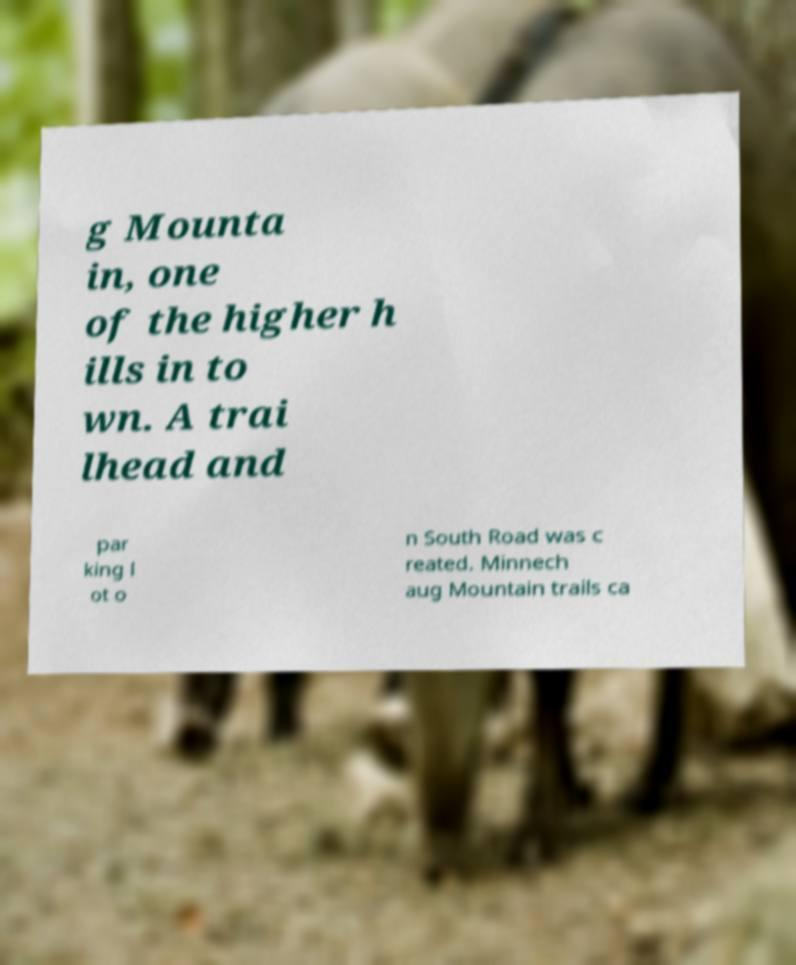Can you accurately transcribe the text from the provided image for me? g Mounta in, one of the higher h ills in to wn. A trai lhead and par king l ot o n South Road was c reated. Minnech aug Mountain trails ca 